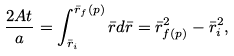Convert formula to latex. <formula><loc_0><loc_0><loc_500><loc_500>\frac { 2 A t } { a } = \int _ { \bar { r } _ { i } } ^ { \bar { r } _ { f } ( p ) } \bar { r } d \bar { r } = \bar { r } _ { f ( p ) } ^ { 2 } - \bar { r } _ { i } ^ { 2 } ,</formula> 